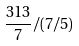<formula> <loc_0><loc_0><loc_500><loc_500>\frac { 3 1 3 } { 7 } / ( 7 / 5 )</formula> 